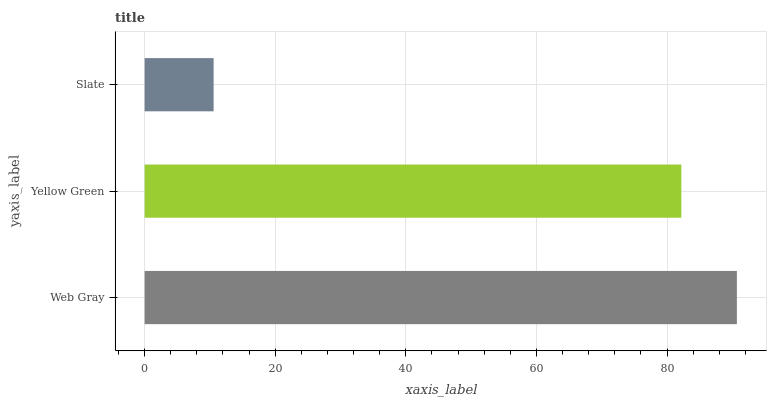Is Slate the minimum?
Answer yes or no. Yes. Is Web Gray the maximum?
Answer yes or no. Yes. Is Yellow Green the minimum?
Answer yes or no. No. Is Yellow Green the maximum?
Answer yes or no. No. Is Web Gray greater than Yellow Green?
Answer yes or no. Yes. Is Yellow Green less than Web Gray?
Answer yes or no. Yes. Is Yellow Green greater than Web Gray?
Answer yes or no. No. Is Web Gray less than Yellow Green?
Answer yes or no. No. Is Yellow Green the high median?
Answer yes or no. Yes. Is Yellow Green the low median?
Answer yes or no. Yes. Is Slate the high median?
Answer yes or no. No. Is Web Gray the low median?
Answer yes or no. No. 